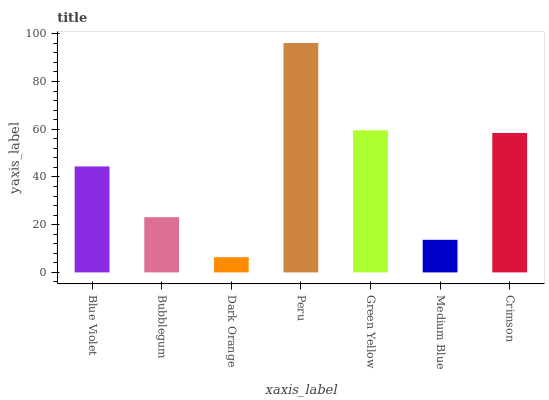Is Dark Orange the minimum?
Answer yes or no. Yes. Is Peru the maximum?
Answer yes or no. Yes. Is Bubblegum the minimum?
Answer yes or no. No. Is Bubblegum the maximum?
Answer yes or no. No. Is Blue Violet greater than Bubblegum?
Answer yes or no. Yes. Is Bubblegum less than Blue Violet?
Answer yes or no. Yes. Is Bubblegum greater than Blue Violet?
Answer yes or no. No. Is Blue Violet less than Bubblegum?
Answer yes or no. No. Is Blue Violet the high median?
Answer yes or no. Yes. Is Blue Violet the low median?
Answer yes or no. Yes. Is Green Yellow the high median?
Answer yes or no. No. Is Medium Blue the low median?
Answer yes or no. No. 